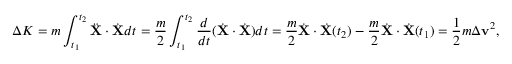Convert formula to latex. <formula><loc_0><loc_0><loc_500><loc_500>\Delta K = m \int _ { t _ { 1 } } ^ { t _ { 2 } } { \ddot { X } } \cdot { \dot { X } } d t = { \frac { m } { 2 } } \int _ { t _ { 1 } } ^ { t _ { 2 } } { \frac { d } { d t } } ( { \dot { X } } \cdot { \dot { X } } ) d t = { \frac { m } { 2 } } { \dot { X } } \cdot { \dot { X } } ( t _ { 2 } ) - { \frac { m } { 2 } } { \dot { X } } \cdot { \dot { X } } ( t _ { 1 } ) = { \frac { 1 } { 2 } } m \Delta v ^ { 2 } ,</formula> 